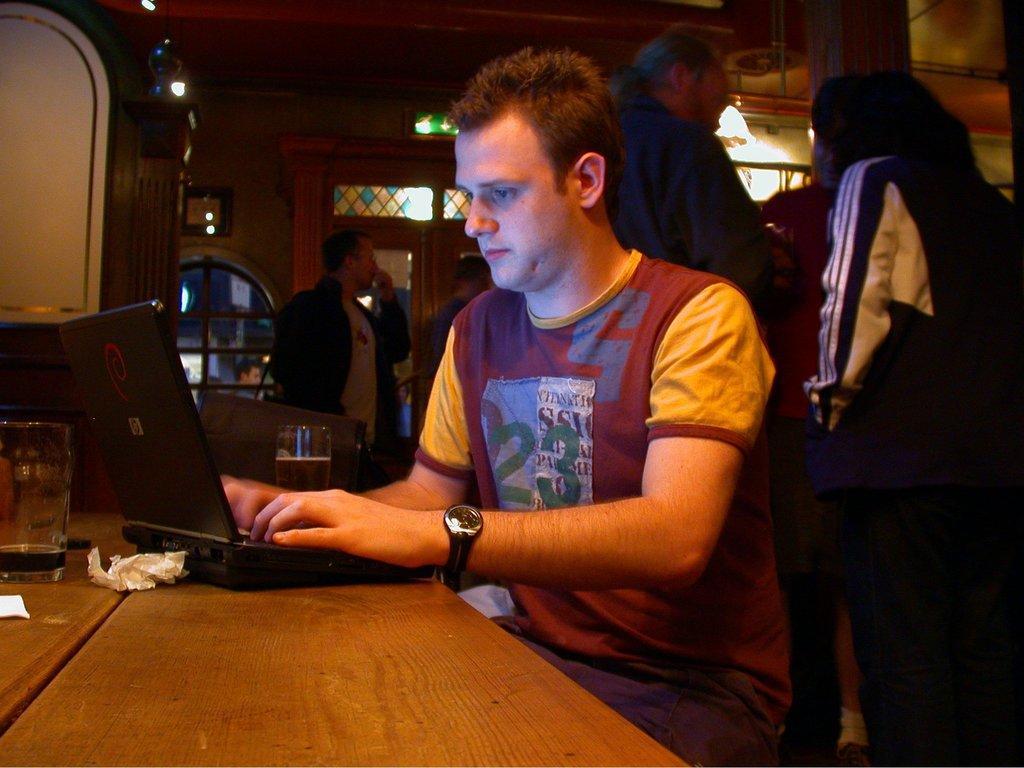How would you summarize this image in a sentence or two? In the middle, a person is sitting on the chair in front of the table on which a glass, laptop is kept. Behind that three person are standing. In the left, a cupboard is there and shelves are visible. A roof top is there on which lamp is mounted. And door visible in the middle. And two person are standing. This image is taken inside a room. 